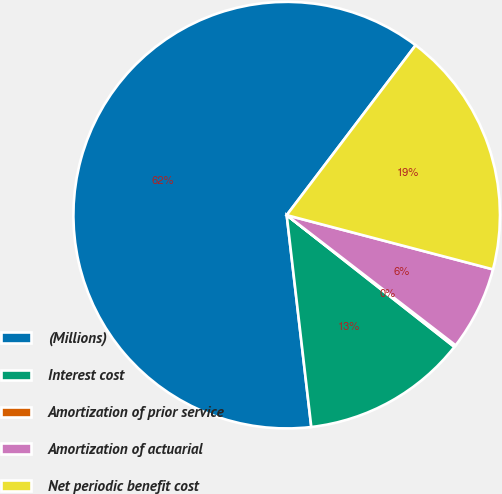Convert chart. <chart><loc_0><loc_0><loc_500><loc_500><pie_chart><fcel>(Millions)<fcel>Interest cost<fcel>Amortization of prior service<fcel>Amortization of actuarial<fcel>Net periodic benefit cost<nl><fcel>62.17%<fcel>12.56%<fcel>0.15%<fcel>6.36%<fcel>18.76%<nl></chart> 